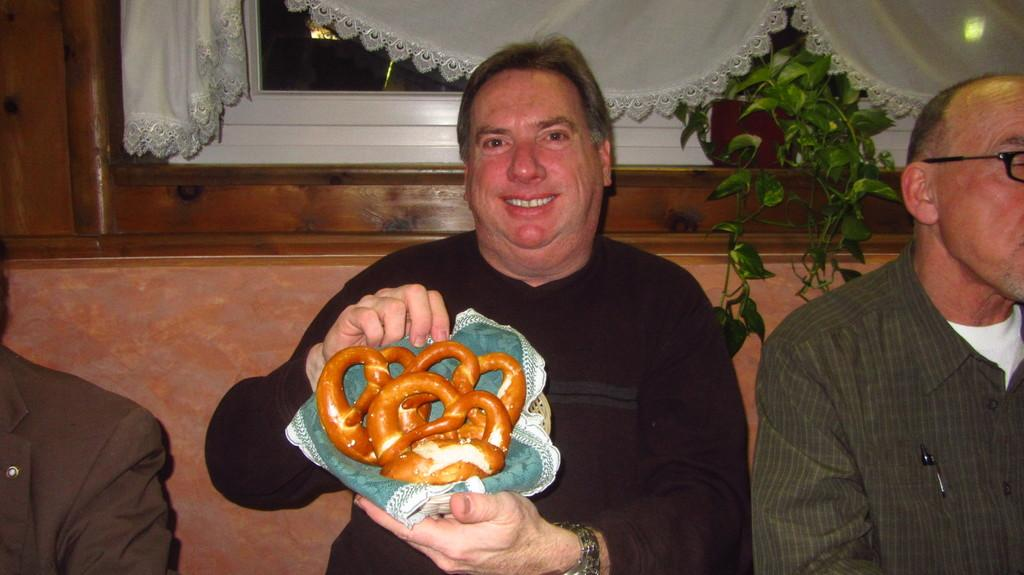How many people are in the image? There are three persons in the image. Can you describe the expression of one of the persons? One of the persons is smiling. What is the smiling person holding? The smiling person is holding a food item. Where is the food item placed? The food item is placed in a basket. What can be seen in the background of the image? There is a window with curtains and a plant visible in the background. What type of cart can be seen in the image? There is no cart present in the image. Is the scene taking place during the night in the image? The image does not provide any information about the time of day, so it cannot be determined if it is night or not. 